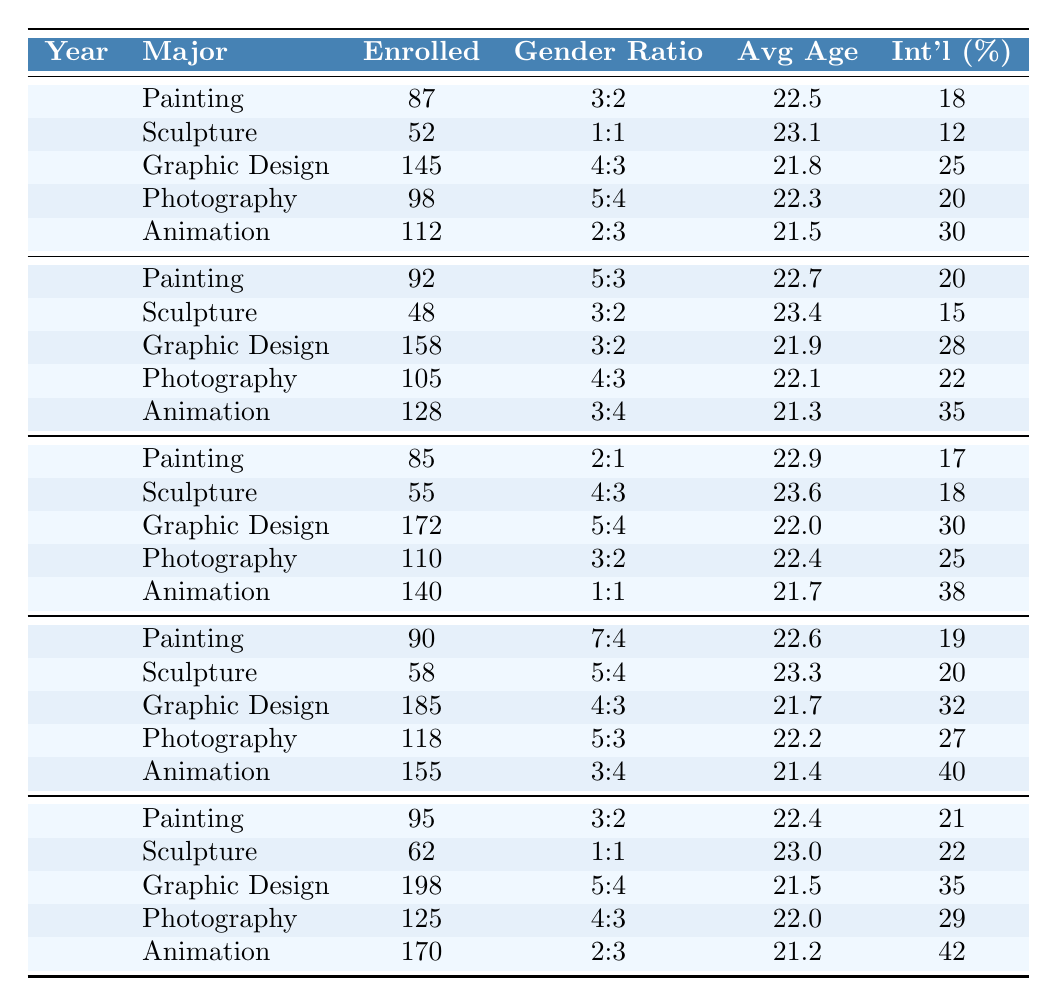What was the total number of students enrolled in Graphic Design in 2022? According to the table, the number of enrolled students in Graphic Design for 2022 is listed as 185. Therefore, the total number of students enrolled in Graphic Design that year is 185.
Answer: 185 Which major had the highest number of enrolled students in 2023? By reviewing the 2023 row of the table, Graphic Design shows the highest enrollment figure at 198 students, which is greater than the other majors' enrollments in the same year.
Answer: Graphic Design What is the average age of students enrolled in Sculpture over the last five years? The ages of students in Sculpture over the last five years are: 23.1 (2019), 23.4 (2020), 23.6 (2021), 23.3 (2022), and 23.0 (2023). Summing these ages gives 23.1 + 23.4 + 23.6 + 23.3 + 23.0 = 115.4. Dividing by 5 yields an average of 115.4 / 5 = 23.08, which rounds to 23.1 when expressed to one decimal place.
Answer: 23.1 What percentage of students were international in Photography in 2020? The data for Photography in 2020 states that the percentage of international students is 22%. Thus, the percentage of international students in that major for that year is simply 22.
Answer: 22% Did the enrollment in Animation increase or decrease from 2019 to 2023? In 2019, there were 112 students enrolled in Animation, while in 2023, there were 170 students. The difference is 170 - 112 = 58, indicating an increase.
Answer: Increase What was the gender ratio for Painting students in 2022, and how does it compare to 2021? The gender ratio for Painting in 2022 is 7:4, and for 2021, it is 2:1. Evaluating these ratios, 7:4 can be expressed in terms of female to male population and is markedly different from the 2:1 ratio, indicating a shift towards more females in 2022 compared to 2021.
Answer: 7:4, more females in 2022 What major had the lowest percentage of international students in 2019? In 2019, the percentages of international students by major are 18% (Painting), 12% (Sculpture), 25% (Graphic Design), 20% (Photography), and 30% (Animation). Among these, Sculpture has the lowest percentage at 12%.
Answer: Sculpture Which year saw the highest total enrollment across all majors? To find which year had the highest total enrollment, we sum up the number of enrolled students for each year: 2019 = 87 + 52 + 145 + 98 + 112 = 494, 2020 = 92 + 48 + 158 + 105 + 128 = 531, 2021 = 85 + 55 + 172 + 110 + 140 = 562, 2022 = 90 + 58 + 185 + 118 + 155 = 606, and 2023 = 95 + 62 + 198 + 125 + 170 = 650. The highest total is from 2023.
Answer: 2023 What is the trend in the enrollment numbers for Painting over the five years shown? Enrollment numbers for Painting were: 87 (2019), 92 (2020), 85 (2021), 90 (2022), and 95 (2023). By examining the numbers, there's a mix of slight increases and decreases, but the overall trend is a general upward movement from 87 to 95 by 2023.
Answer: Upward trend Was the gender ratio in Sculpture consistent from 2019 to 2023? The gender ratios for Sculpture in the years listed are: 2019 (1:1), 2020 (3:2), 2021 (4:3), 2022 (5:4), and 2023 (1:1). A comparison shows fluctuations in ratios indicating inconsistency over the years.
Answer: No, it was not consistent 